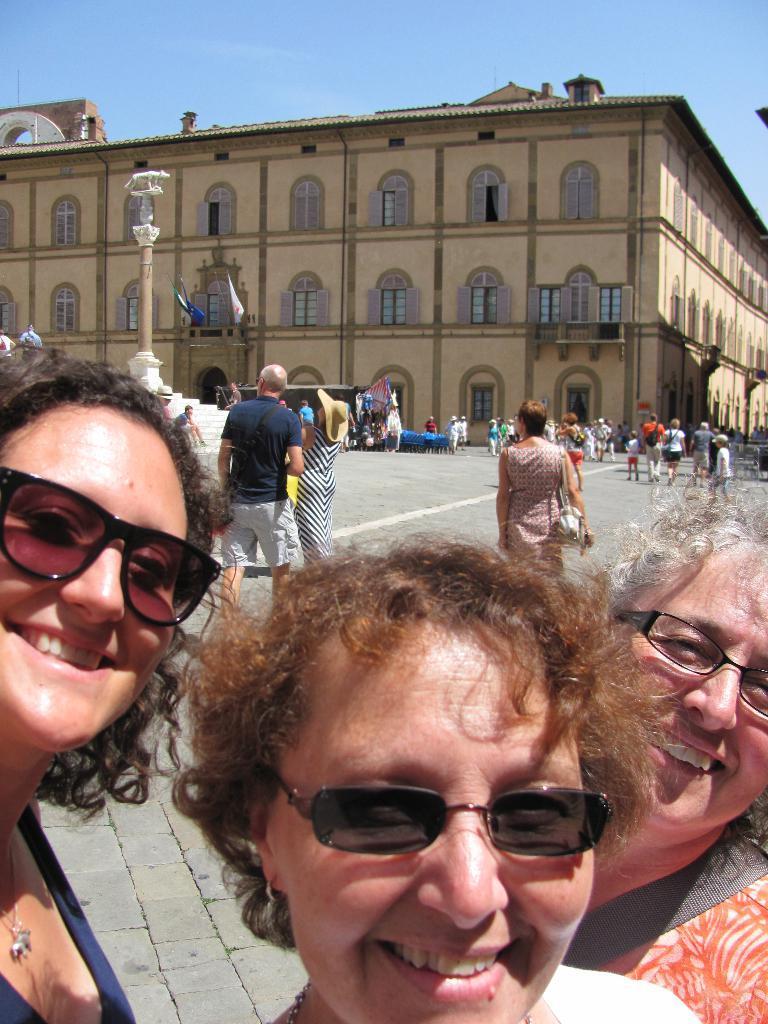How would you summarize this image in a sentence or two? In the foreground of the image there are ladies smiling. In the background of the image there is a building. There are many people in the image. At the top of the image there is sky. 